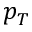<formula> <loc_0><loc_0><loc_500><loc_500>p _ { T }</formula> 